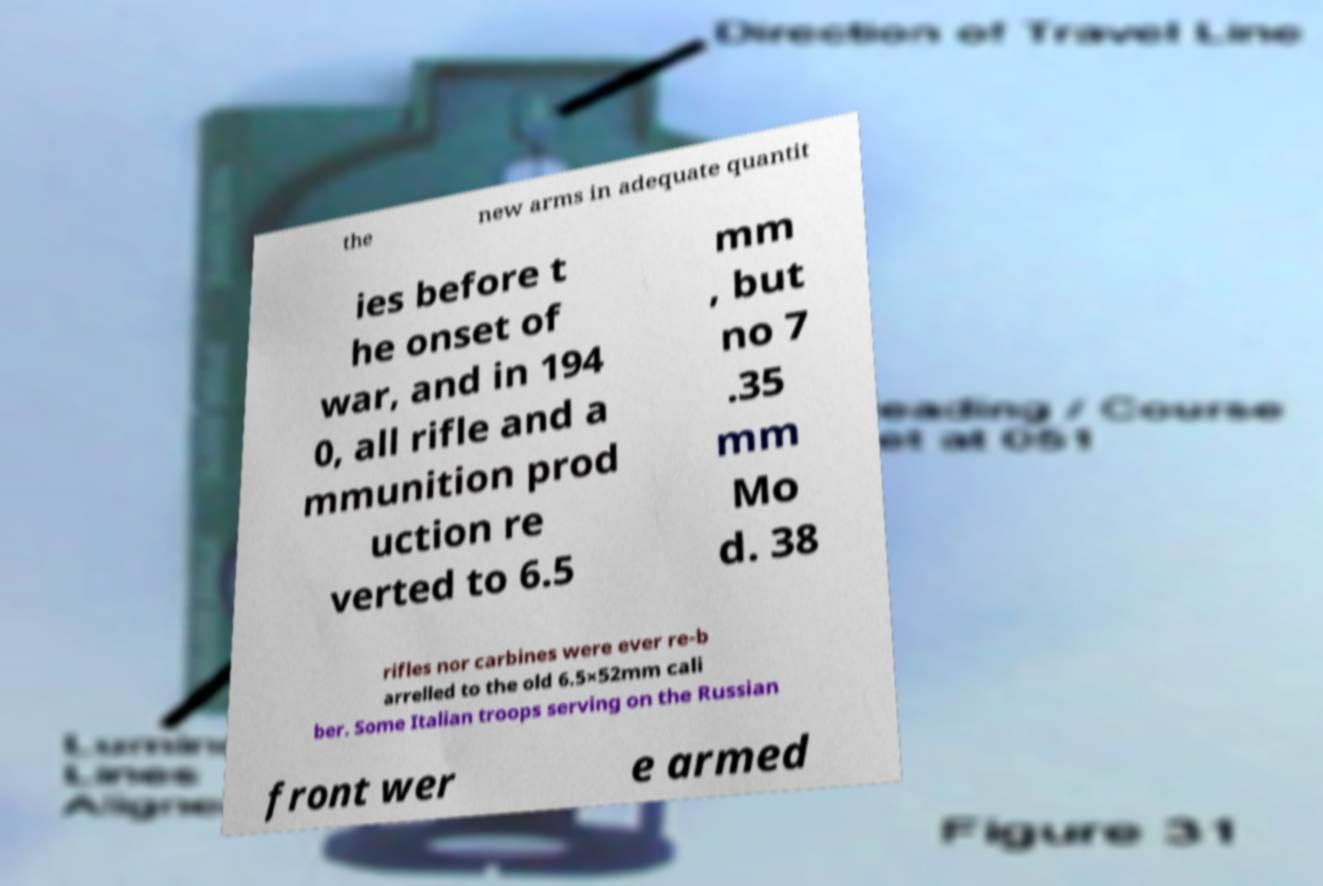There's text embedded in this image that I need extracted. Can you transcribe it verbatim? the new arms in adequate quantit ies before t he onset of war, and in 194 0, all rifle and a mmunition prod uction re verted to 6.5 mm , but no 7 .35 mm Mo d. 38 rifles nor carbines were ever re-b arrelled to the old 6.5×52mm cali ber. Some Italian troops serving on the Russian front wer e armed 